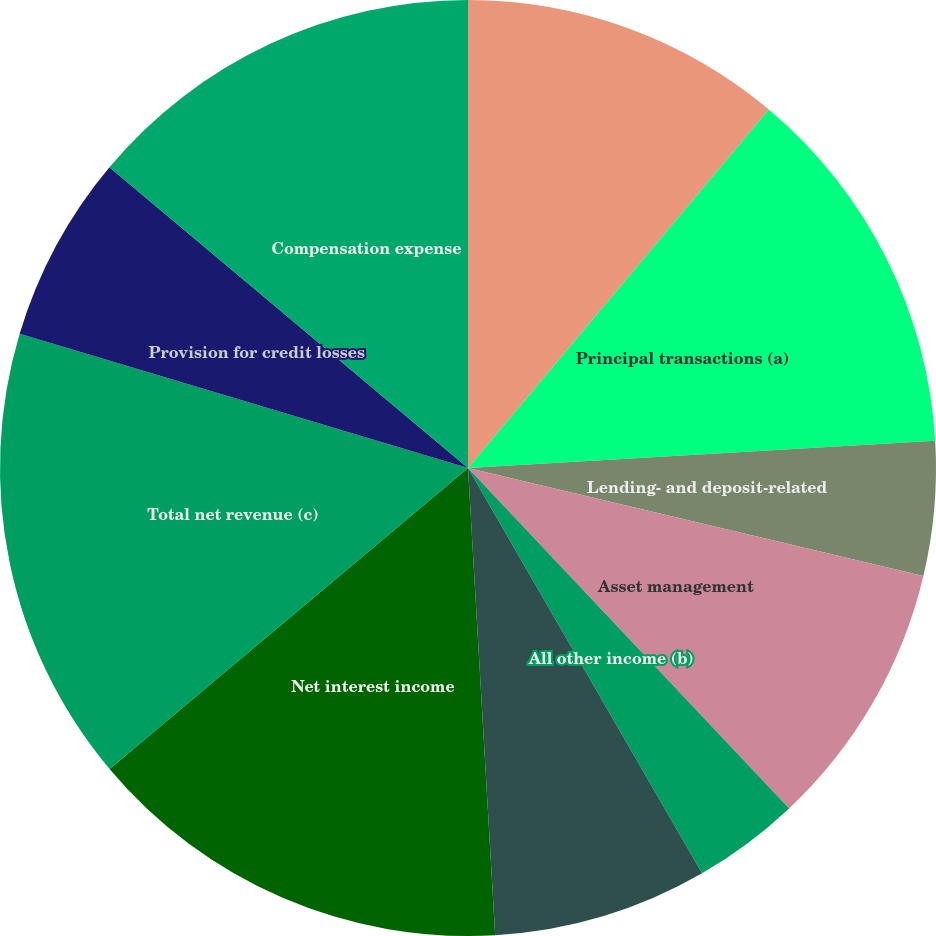Convert chart. <chart><loc_0><loc_0><loc_500><loc_500><pie_chart><fcel>Investment banking fees<fcel>Principal transactions (a)<fcel>Lending- and deposit-related<fcel>Asset management<fcel>All other income (b)<fcel>Noninterest revenue<fcel>Net interest income<fcel>Total net revenue (c)<fcel>Provision for credit losses<fcel>Compensation expense<nl><fcel>11.11%<fcel>12.96%<fcel>4.63%<fcel>9.26%<fcel>3.7%<fcel>7.41%<fcel>14.81%<fcel>15.74%<fcel>6.48%<fcel>13.89%<nl></chart> 